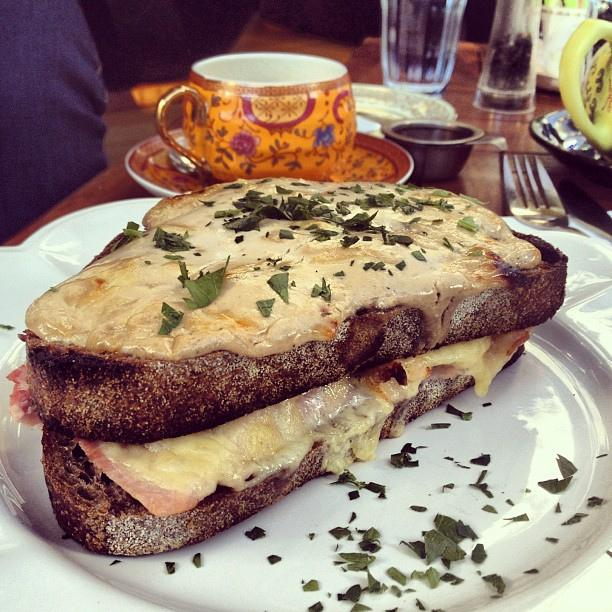What is in the sandwich?

Choices:
A) cheese
B) pork chop
C) purple onion
D) bagel cheese 